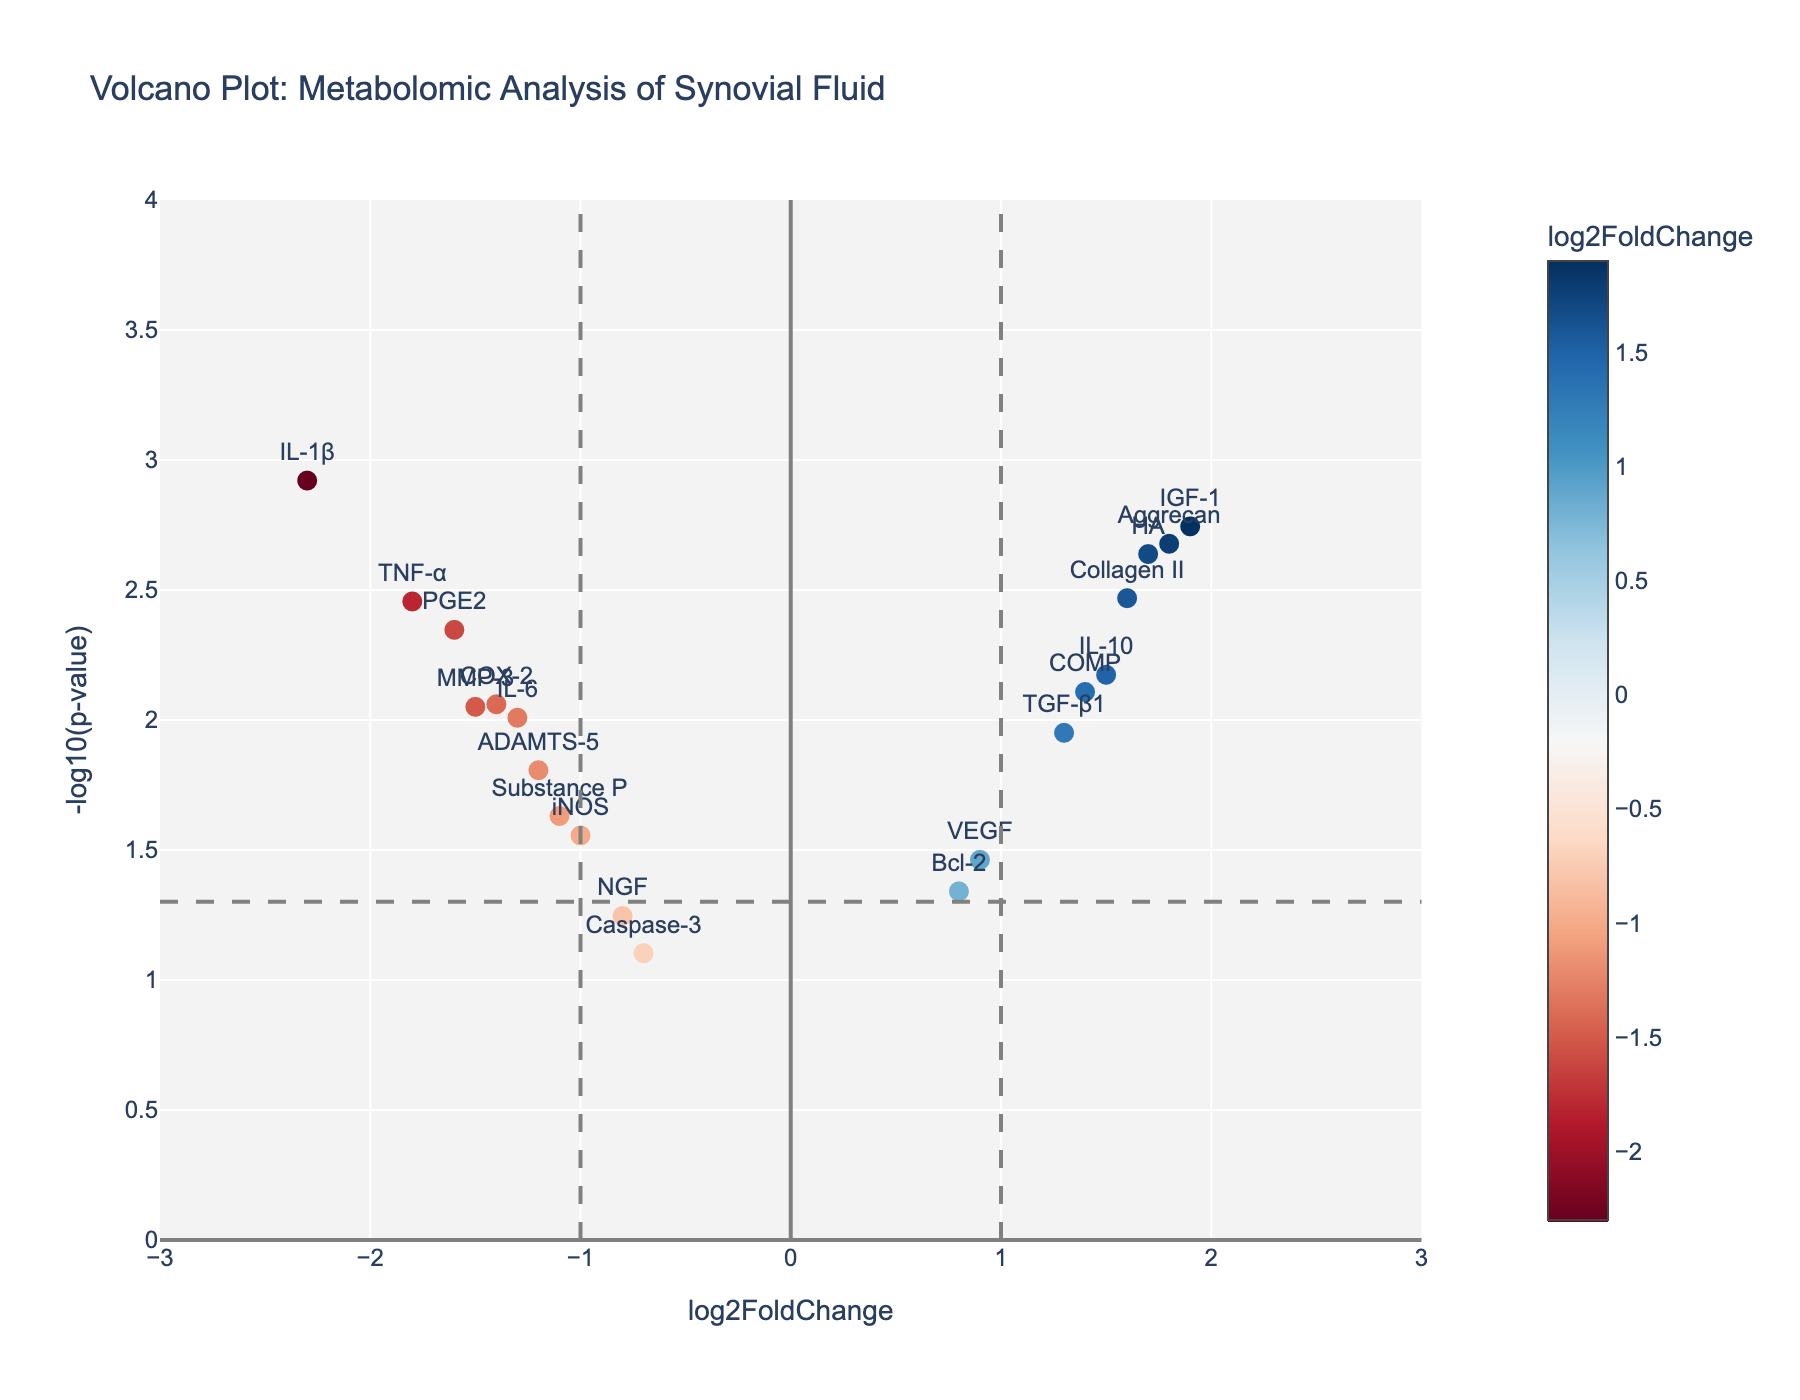What's the title of the figure? The title of the figure is displayed prominently at the top and describes the overall content of the plot.
Answer: Volcano Plot: Metabolomic Analysis of Synovial Fluid How many data points are represented in the figure? Each gene in the given dataset corresponds to one data point shown in the plot. Count the genes listed to find the total number.
Answer: 19 Which gene has the highest log2FoldChange? Identify the point furthest to the right on the x-axis since it represents the highest log2FoldChange.
Answer: IGF-1 Which gene has the lowest p-value? Locate the point that is highest on the y-axis, representing the lowest (most significant) p-value.
Answer: IL-1β What is the color coding based on in the plot? Examine the color bar shown in the figure; the color corresponds to different log2FoldChange values.
Answer: log2FoldChange What are the threshold lines on the plot? The plot includes vertical and horizontal dashed lines; these lines act as thresholds. Identify what they represent based on their positions.
Answer: Vertical lines at log2FoldChange = 1 and -1, horizontal line at p-value = 0.05 Which gene has the highest negative log2FoldChange and is also significant? Look for the gene farthest to the left past the vertical line at log2FoldChange = -1, and above the horizontal line at p-value = 0.05.
Answer: IL-1β Which gene near the cutoff has a p-value slightly greater than 0.05? Find the gene closest to but just above the horizontal line at p-value = 0.05.
Answer: Caspase-3 